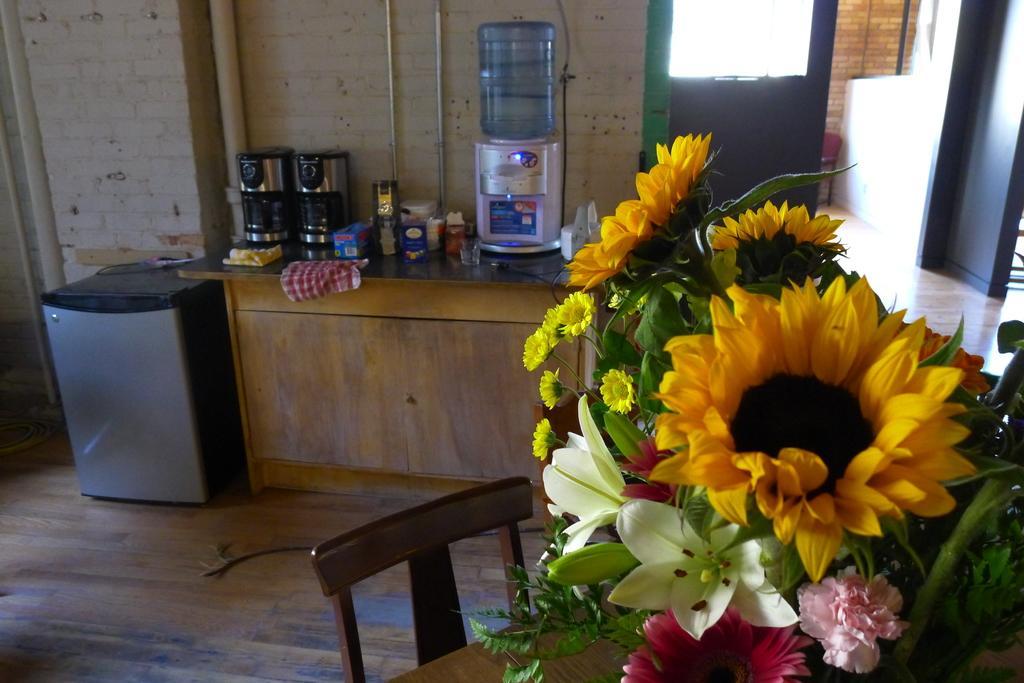In one or two sentences, can you explain what this image depicts? The picture is taken inside a room. In the right there is a bouquet on a table. Beside the table there is a chair. On the counter there is water filter, coffee machine, cloth, few other things are there. Beside it there is a washing machine. in the top right there is an entrance. 